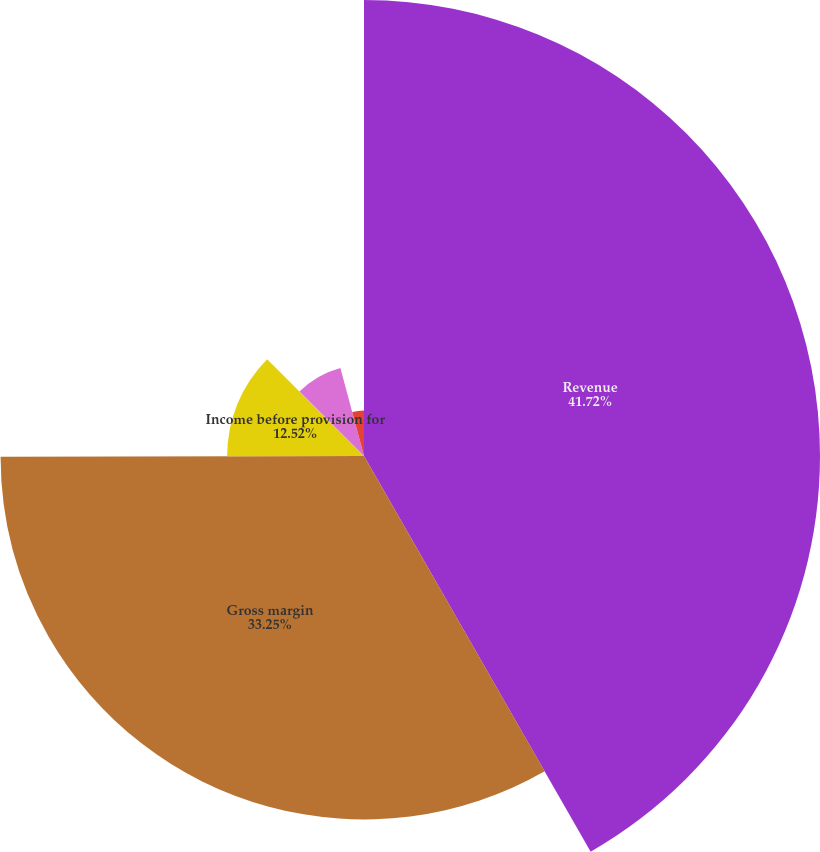Convert chart. <chart><loc_0><loc_0><loc_500><loc_500><pie_chart><fcel>Revenue<fcel>Gross margin<fcel>Income before provision for<fcel>Net income(1)<fcel>Basic<fcel>Diluted<nl><fcel>41.72%<fcel>33.25%<fcel>12.52%<fcel>8.34%<fcel>4.17%<fcel>0.0%<nl></chart> 